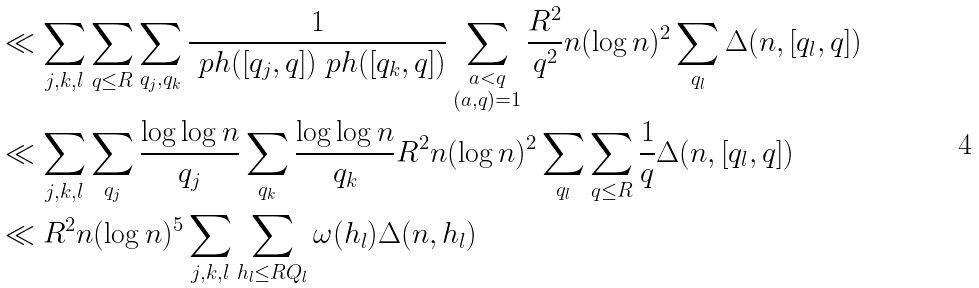Convert formula to latex. <formula><loc_0><loc_0><loc_500><loc_500>& \ll \sum _ { j , k , l } \sum _ { q \leq R } \sum _ { q _ { j } , q _ { k } } \frac { 1 } { \ p h ( [ q _ { j } , q ] ) \ p h ( [ q _ { k } , q ] ) } \sum _ { \substack { a < q \\ ( a , q ) = 1 } } \frac { R ^ { 2 } } { q ^ { 2 } } n ( \log n ) ^ { 2 } \sum _ { q _ { l } } \Delta ( n , [ q _ { l } , q ] ) \\ & \ll \sum _ { j , k , l } \sum _ { q _ { j } } \frac { \log \log n } { q _ { j } } \sum _ { q _ { k } } \frac { \log \log n } { q _ { k } } R ^ { 2 } n ( \log n ) ^ { 2 } \sum _ { q _ { l } } \sum _ { q \leq R } \frac { 1 } { q } \Delta ( n , [ q _ { l } , q ] ) \\ & \ll R ^ { 2 } n ( \log n ) ^ { 5 } \sum _ { j , k , l } \sum _ { h _ { l } \leq R Q _ { l } } \omega ( h _ { l } ) \Delta ( n , h _ { l } )</formula> 